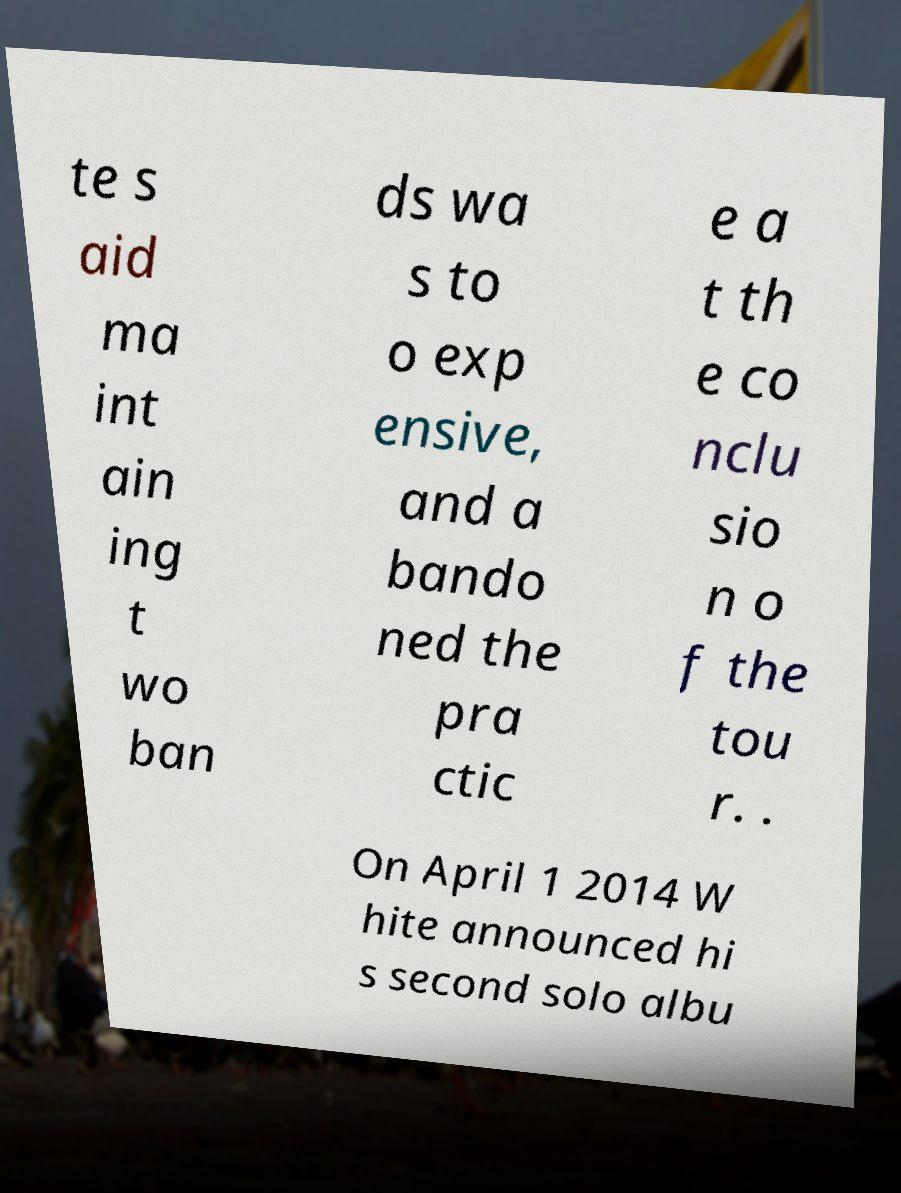Please read and relay the text visible in this image. What does it say? te s aid ma int ain ing t wo ban ds wa s to o exp ensive, and a bando ned the pra ctic e a t th e co nclu sio n o f the tou r. . On April 1 2014 W hite announced hi s second solo albu 